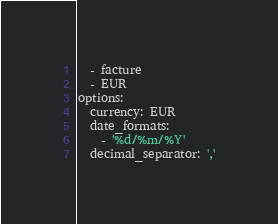Convert code to text. <code><loc_0><loc_0><loc_500><loc_500><_YAML_>  - facture
  - EUR
options:
  currency: EUR
  date_formats:
    - '%d/%m/%Y'
  decimal_separator: ','
</code> 